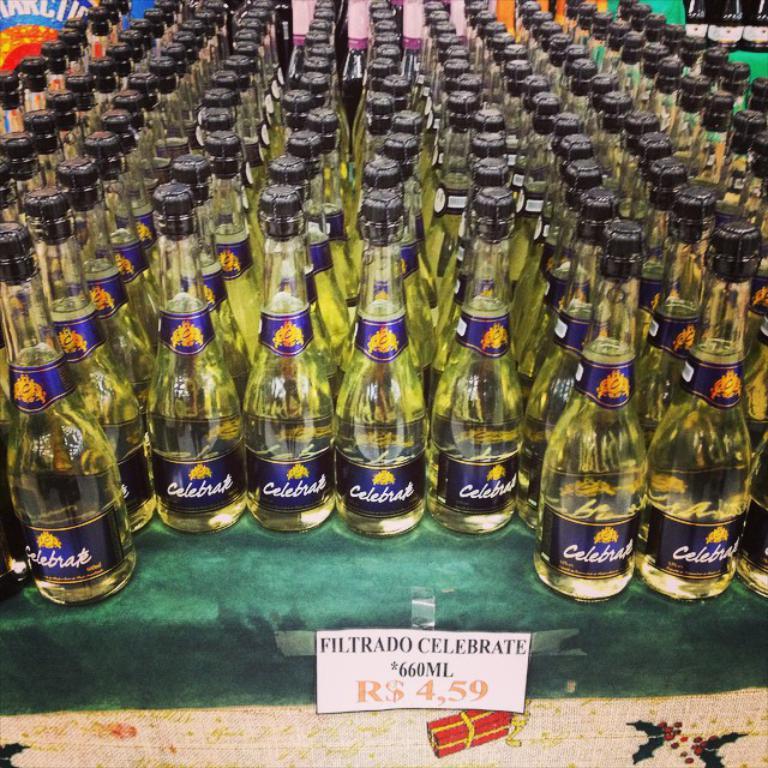What is the price of this champagne?
Your response must be concise. 4.59. 